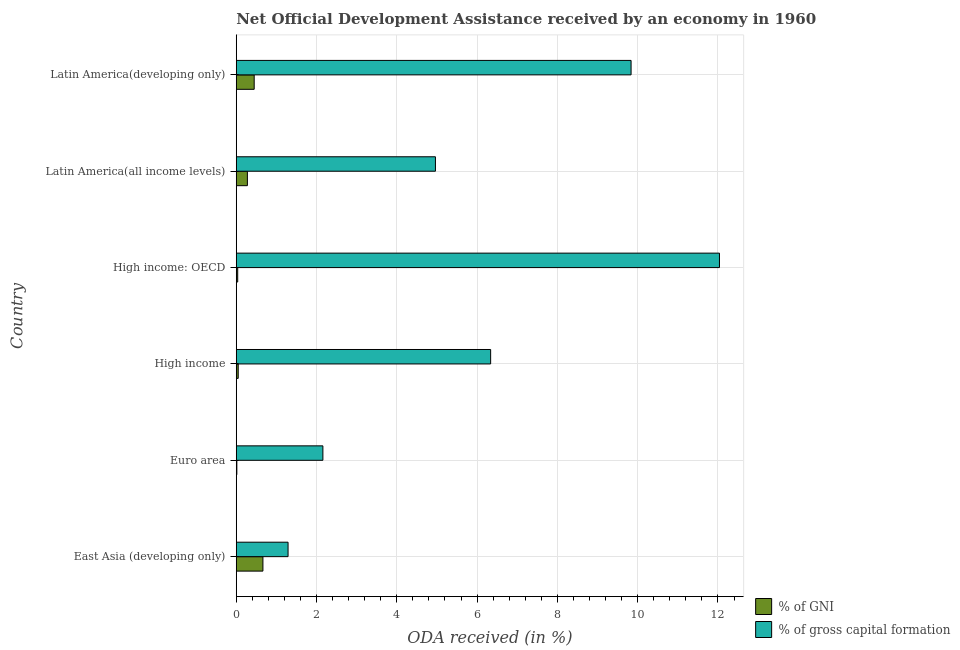How many different coloured bars are there?
Provide a short and direct response. 2. Are the number of bars per tick equal to the number of legend labels?
Your answer should be compact. Yes. How many bars are there on the 2nd tick from the bottom?
Offer a very short reply. 2. What is the oda received as percentage of gni in High income?
Offer a terse response. 0.05. Across all countries, what is the maximum oda received as percentage of gni?
Provide a short and direct response. 0.66. Across all countries, what is the minimum oda received as percentage of gross capital formation?
Give a very brief answer. 1.29. In which country was the oda received as percentage of gross capital formation maximum?
Make the answer very short. High income: OECD. In which country was the oda received as percentage of gross capital formation minimum?
Provide a short and direct response. East Asia (developing only). What is the total oda received as percentage of gross capital formation in the graph?
Offer a very short reply. 36.62. What is the difference between the oda received as percentage of gross capital formation in High income: OECD and that in Latin America(developing only)?
Offer a very short reply. 2.2. What is the difference between the oda received as percentage of gross capital formation in High income and the oda received as percentage of gni in Euro area?
Your answer should be compact. 6.32. What is the average oda received as percentage of gross capital formation per country?
Provide a short and direct response. 6.1. What is the difference between the oda received as percentage of gni and oda received as percentage of gross capital formation in High income?
Give a very brief answer. -6.29. What is the ratio of the oda received as percentage of gross capital formation in East Asia (developing only) to that in Latin America(all income levels)?
Ensure brevity in your answer.  0.26. Is the difference between the oda received as percentage of gni in Euro area and High income greater than the difference between the oda received as percentage of gross capital formation in Euro area and High income?
Provide a succinct answer. Yes. What is the difference between the highest and the second highest oda received as percentage of gni?
Your answer should be very brief. 0.22. What is the difference between the highest and the lowest oda received as percentage of gni?
Offer a terse response. 0.65. Is the sum of the oda received as percentage of gni in Latin America(all income levels) and Latin America(developing only) greater than the maximum oda received as percentage of gross capital formation across all countries?
Your answer should be compact. No. What does the 1st bar from the top in High income: OECD represents?
Keep it short and to the point. % of gross capital formation. What does the 1st bar from the bottom in East Asia (developing only) represents?
Provide a short and direct response. % of GNI. How many bars are there?
Provide a succinct answer. 12. Are all the bars in the graph horizontal?
Offer a very short reply. Yes. What is the difference between two consecutive major ticks on the X-axis?
Ensure brevity in your answer.  2. Does the graph contain any zero values?
Your answer should be very brief. No. Does the graph contain grids?
Keep it short and to the point. Yes. Where does the legend appear in the graph?
Keep it short and to the point. Bottom right. What is the title of the graph?
Your answer should be very brief. Net Official Development Assistance received by an economy in 1960. What is the label or title of the X-axis?
Offer a very short reply. ODA received (in %). What is the ODA received (in %) in % of GNI in East Asia (developing only)?
Your response must be concise. 0.66. What is the ODA received (in %) in % of gross capital formation in East Asia (developing only)?
Keep it short and to the point. 1.29. What is the ODA received (in %) of % of GNI in Euro area?
Make the answer very short. 0.01. What is the ODA received (in %) in % of gross capital formation in Euro area?
Provide a succinct answer. 2.16. What is the ODA received (in %) in % of GNI in High income?
Your response must be concise. 0.05. What is the ODA received (in %) in % of gross capital formation in High income?
Keep it short and to the point. 6.34. What is the ODA received (in %) in % of GNI in High income: OECD?
Offer a terse response. 0.04. What is the ODA received (in %) in % of gross capital formation in High income: OECD?
Your response must be concise. 12.04. What is the ODA received (in %) in % of GNI in Latin America(all income levels)?
Your response must be concise. 0.28. What is the ODA received (in %) in % of gross capital formation in Latin America(all income levels)?
Your response must be concise. 4.96. What is the ODA received (in %) in % of GNI in Latin America(developing only)?
Offer a terse response. 0.45. What is the ODA received (in %) in % of gross capital formation in Latin America(developing only)?
Ensure brevity in your answer.  9.84. Across all countries, what is the maximum ODA received (in %) in % of GNI?
Provide a short and direct response. 0.66. Across all countries, what is the maximum ODA received (in %) of % of gross capital formation?
Give a very brief answer. 12.04. Across all countries, what is the minimum ODA received (in %) in % of GNI?
Offer a very short reply. 0.01. Across all countries, what is the minimum ODA received (in %) of % of gross capital formation?
Your answer should be compact. 1.29. What is the total ODA received (in %) in % of GNI in the graph?
Provide a short and direct response. 1.49. What is the total ODA received (in %) in % of gross capital formation in the graph?
Offer a terse response. 36.62. What is the difference between the ODA received (in %) of % of GNI in East Asia (developing only) and that in Euro area?
Provide a short and direct response. 0.65. What is the difference between the ODA received (in %) in % of gross capital formation in East Asia (developing only) and that in Euro area?
Make the answer very short. -0.87. What is the difference between the ODA received (in %) of % of GNI in East Asia (developing only) and that in High income?
Offer a very short reply. 0.62. What is the difference between the ODA received (in %) of % of gross capital formation in East Asia (developing only) and that in High income?
Offer a terse response. -5.05. What is the difference between the ODA received (in %) of % of GNI in East Asia (developing only) and that in High income: OECD?
Your answer should be compact. 0.63. What is the difference between the ODA received (in %) in % of gross capital formation in East Asia (developing only) and that in High income: OECD?
Offer a terse response. -10.75. What is the difference between the ODA received (in %) of % of GNI in East Asia (developing only) and that in Latin America(all income levels)?
Your answer should be compact. 0.39. What is the difference between the ODA received (in %) of % of gross capital formation in East Asia (developing only) and that in Latin America(all income levels)?
Provide a succinct answer. -3.67. What is the difference between the ODA received (in %) of % of GNI in East Asia (developing only) and that in Latin America(developing only)?
Your answer should be very brief. 0.22. What is the difference between the ODA received (in %) in % of gross capital formation in East Asia (developing only) and that in Latin America(developing only)?
Your response must be concise. -8.55. What is the difference between the ODA received (in %) of % of GNI in Euro area and that in High income?
Offer a terse response. -0.03. What is the difference between the ODA received (in %) of % of gross capital formation in Euro area and that in High income?
Ensure brevity in your answer.  -4.18. What is the difference between the ODA received (in %) of % of GNI in Euro area and that in High income: OECD?
Ensure brevity in your answer.  -0.02. What is the difference between the ODA received (in %) in % of gross capital formation in Euro area and that in High income: OECD?
Offer a very short reply. -9.88. What is the difference between the ODA received (in %) in % of GNI in Euro area and that in Latin America(all income levels)?
Make the answer very short. -0.26. What is the difference between the ODA received (in %) in % of gross capital formation in Euro area and that in Latin America(all income levels)?
Make the answer very short. -2.8. What is the difference between the ODA received (in %) in % of GNI in Euro area and that in Latin America(developing only)?
Provide a short and direct response. -0.43. What is the difference between the ODA received (in %) of % of gross capital formation in Euro area and that in Latin America(developing only)?
Provide a short and direct response. -7.68. What is the difference between the ODA received (in %) in % of GNI in High income and that in High income: OECD?
Provide a succinct answer. 0.01. What is the difference between the ODA received (in %) in % of gross capital formation in High income and that in High income: OECD?
Offer a terse response. -5.7. What is the difference between the ODA received (in %) of % of GNI in High income and that in Latin America(all income levels)?
Ensure brevity in your answer.  -0.23. What is the difference between the ODA received (in %) of % of gross capital formation in High income and that in Latin America(all income levels)?
Keep it short and to the point. 1.38. What is the difference between the ODA received (in %) of % of GNI in High income and that in Latin America(developing only)?
Provide a succinct answer. -0.4. What is the difference between the ODA received (in %) in % of gross capital formation in High income and that in Latin America(developing only)?
Offer a very short reply. -3.5. What is the difference between the ODA received (in %) in % of GNI in High income: OECD and that in Latin America(all income levels)?
Keep it short and to the point. -0.24. What is the difference between the ODA received (in %) in % of gross capital formation in High income: OECD and that in Latin America(all income levels)?
Your answer should be very brief. 7.08. What is the difference between the ODA received (in %) in % of GNI in High income: OECD and that in Latin America(developing only)?
Your response must be concise. -0.41. What is the difference between the ODA received (in %) of % of gross capital formation in High income: OECD and that in Latin America(developing only)?
Offer a terse response. 2.2. What is the difference between the ODA received (in %) in % of GNI in Latin America(all income levels) and that in Latin America(developing only)?
Your answer should be compact. -0.17. What is the difference between the ODA received (in %) in % of gross capital formation in Latin America(all income levels) and that in Latin America(developing only)?
Your answer should be compact. -4.87. What is the difference between the ODA received (in %) of % of GNI in East Asia (developing only) and the ODA received (in %) of % of gross capital formation in Euro area?
Offer a terse response. -1.49. What is the difference between the ODA received (in %) in % of GNI in East Asia (developing only) and the ODA received (in %) in % of gross capital formation in High income?
Make the answer very short. -5.67. What is the difference between the ODA received (in %) in % of GNI in East Asia (developing only) and the ODA received (in %) in % of gross capital formation in High income: OECD?
Offer a very short reply. -11.37. What is the difference between the ODA received (in %) in % of GNI in East Asia (developing only) and the ODA received (in %) in % of gross capital formation in Latin America(all income levels)?
Your response must be concise. -4.3. What is the difference between the ODA received (in %) of % of GNI in East Asia (developing only) and the ODA received (in %) of % of gross capital formation in Latin America(developing only)?
Keep it short and to the point. -9.17. What is the difference between the ODA received (in %) of % of GNI in Euro area and the ODA received (in %) of % of gross capital formation in High income?
Ensure brevity in your answer.  -6.32. What is the difference between the ODA received (in %) of % of GNI in Euro area and the ODA received (in %) of % of gross capital formation in High income: OECD?
Provide a short and direct response. -12.02. What is the difference between the ODA received (in %) in % of GNI in Euro area and the ODA received (in %) in % of gross capital formation in Latin America(all income levels)?
Offer a terse response. -4.95. What is the difference between the ODA received (in %) in % of GNI in Euro area and the ODA received (in %) in % of gross capital formation in Latin America(developing only)?
Provide a short and direct response. -9.82. What is the difference between the ODA received (in %) in % of GNI in High income and the ODA received (in %) in % of gross capital formation in High income: OECD?
Keep it short and to the point. -11.99. What is the difference between the ODA received (in %) of % of GNI in High income and the ODA received (in %) of % of gross capital formation in Latin America(all income levels)?
Your answer should be compact. -4.91. What is the difference between the ODA received (in %) in % of GNI in High income and the ODA received (in %) in % of gross capital formation in Latin America(developing only)?
Your answer should be very brief. -9.79. What is the difference between the ODA received (in %) of % of GNI in High income: OECD and the ODA received (in %) of % of gross capital formation in Latin America(all income levels)?
Provide a short and direct response. -4.93. What is the difference between the ODA received (in %) of % of GNI in High income: OECD and the ODA received (in %) of % of gross capital formation in Latin America(developing only)?
Give a very brief answer. -9.8. What is the difference between the ODA received (in %) of % of GNI in Latin America(all income levels) and the ODA received (in %) of % of gross capital formation in Latin America(developing only)?
Provide a short and direct response. -9.56. What is the average ODA received (in %) in % of GNI per country?
Offer a very short reply. 0.25. What is the average ODA received (in %) in % of gross capital formation per country?
Provide a short and direct response. 6.1. What is the difference between the ODA received (in %) in % of GNI and ODA received (in %) in % of gross capital formation in East Asia (developing only)?
Offer a very short reply. -0.63. What is the difference between the ODA received (in %) in % of GNI and ODA received (in %) in % of gross capital formation in Euro area?
Keep it short and to the point. -2.14. What is the difference between the ODA received (in %) of % of GNI and ODA received (in %) of % of gross capital formation in High income?
Your answer should be compact. -6.29. What is the difference between the ODA received (in %) in % of GNI and ODA received (in %) in % of gross capital formation in High income: OECD?
Provide a short and direct response. -12. What is the difference between the ODA received (in %) in % of GNI and ODA received (in %) in % of gross capital formation in Latin America(all income levels)?
Provide a succinct answer. -4.68. What is the difference between the ODA received (in %) in % of GNI and ODA received (in %) in % of gross capital formation in Latin America(developing only)?
Ensure brevity in your answer.  -9.39. What is the ratio of the ODA received (in %) of % of GNI in East Asia (developing only) to that in Euro area?
Your response must be concise. 45.11. What is the ratio of the ODA received (in %) in % of gross capital formation in East Asia (developing only) to that in Euro area?
Ensure brevity in your answer.  0.6. What is the ratio of the ODA received (in %) in % of GNI in East Asia (developing only) to that in High income?
Offer a terse response. 13.52. What is the ratio of the ODA received (in %) in % of gross capital formation in East Asia (developing only) to that in High income?
Ensure brevity in your answer.  0.2. What is the ratio of the ODA received (in %) of % of GNI in East Asia (developing only) to that in High income: OECD?
Give a very brief answer. 18.48. What is the ratio of the ODA received (in %) of % of gross capital formation in East Asia (developing only) to that in High income: OECD?
Offer a very short reply. 0.11. What is the ratio of the ODA received (in %) in % of GNI in East Asia (developing only) to that in Latin America(all income levels)?
Ensure brevity in your answer.  2.4. What is the ratio of the ODA received (in %) in % of gross capital formation in East Asia (developing only) to that in Latin America(all income levels)?
Provide a succinct answer. 0.26. What is the ratio of the ODA received (in %) of % of GNI in East Asia (developing only) to that in Latin America(developing only)?
Ensure brevity in your answer.  1.49. What is the ratio of the ODA received (in %) in % of gross capital formation in East Asia (developing only) to that in Latin America(developing only)?
Offer a terse response. 0.13. What is the ratio of the ODA received (in %) of % of GNI in Euro area to that in High income?
Your answer should be compact. 0.3. What is the ratio of the ODA received (in %) in % of gross capital formation in Euro area to that in High income?
Keep it short and to the point. 0.34. What is the ratio of the ODA received (in %) of % of GNI in Euro area to that in High income: OECD?
Your answer should be compact. 0.41. What is the ratio of the ODA received (in %) of % of gross capital formation in Euro area to that in High income: OECD?
Make the answer very short. 0.18. What is the ratio of the ODA received (in %) of % of GNI in Euro area to that in Latin America(all income levels)?
Your answer should be very brief. 0.05. What is the ratio of the ODA received (in %) in % of gross capital formation in Euro area to that in Latin America(all income levels)?
Offer a very short reply. 0.43. What is the ratio of the ODA received (in %) in % of GNI in Euro area to that in Latin America(developing only)?
Keep it short and to the point. 0.03. What is the ratio of the ODA received (in %) in % of gross capital formation in Euro area to that in Latin America(developing only)?
Give a very brief answer. 0.22. What is the ratio of the ODA received (in %) of % of GNI in High income to that in High income: OECD?
Your answer should be compact. 1.37. What is the ratio of the ODA received (in %) of % of gross capital formation in High income to that in High income: OECD?
Your answer should be compact. 0.53. What is the ratio of the ODA received (in %) in % of GNI in High income to that in Latin America(all income levels)?
Offer a very short reply. 0.18. What is the ratio of the ODA received (in %) in % of gross capital formation in High income to that in Latin America(all income levels)?
Offer a terse response. 1.28. What is the ratio of the ODA received (in %) in % of GNI in High income to that in Latin America(developing only)?
Ensure brevity in your answer.  0.11. What is the ratio of the ODA received (in %) in % of gross capital formation in High income to that in Latin America(developing only)?
Your answer should be compact. 0.64. What is the ratio of the ODA received (in %) of % of GNI in High income: OECD to that in Latin America(all income levels)?
Your answer should be very brief. 0.13. What is the ratio of the ODA received (in %) of % of gross capital formation in High income: OECD to that in Latin America(all income levels)?
Your response must be concise. 2.43. What is the ratio of the ODA received (in %) of % of GNI in High income: OECD to that in Latin America(developing only)?
Give a very brief answer. 0.08. What is the ratio of the ODA received (in %) in % of gross capital formation in High income: OECD to that in Latin America(developing only)?
Keep it short and to the point. 1.22. What is the ratio of the ODA received (in %) in % of GNI in Latin America(all income levels) to that in Latin America(developing only)?
Offer a terse response. 0.62. What is the ratio of the ODA received (in %) of % of gross capital formation in Latin America(all income levels) to that in Latin America(developing only)?
Make the answer very short. 0.5. What is the difference between the highest and the second highest ODA received (in %) of % of GNI?
Provide a succinct answer. 0.22. What is the difference between the highest and the second highest ODA received (in %) in % of gross capital formation?
Offer a very short reply. 2.2. What is the difference between the highest and the lowest ODA received (in %) in % of GNI?
Keep it short and to the point. 0.65. What is the difference between the highest and the lowest ODA received (in %) of % of gross capital formation?
Offer a very short reply. 10.75. 